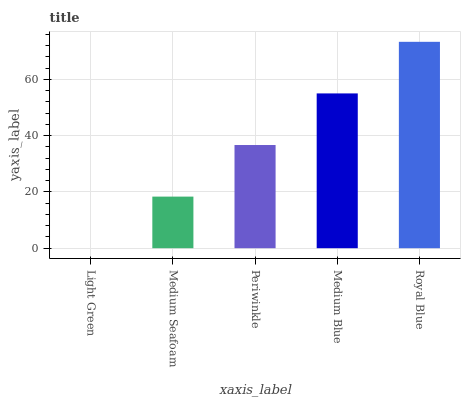Is Medium Seafoam the minimum?
Answer yes or no. No. Is Medium Seafoam the maximum?
Answer yes or no. No. Is Medium Seafoam greater than Light Green?
Answer yes or no. Yes. Is Light Green less than Medium Seafoam?
Answer yes or no. Yes. Is Light Green greater than Medium Seafoam?
Answer yes or no. No. Is Medium Seafoam less than Light Green?
Answer yes or no. No. Is Periwinkle the high median?
Answer yes or no. Yes. Is Periwinkle the low median?
Answer yes or no. Yes. Is Light Green the high median?
Answer yes or no. No. Is Light Green the low median?
Answer yes or no. No. 